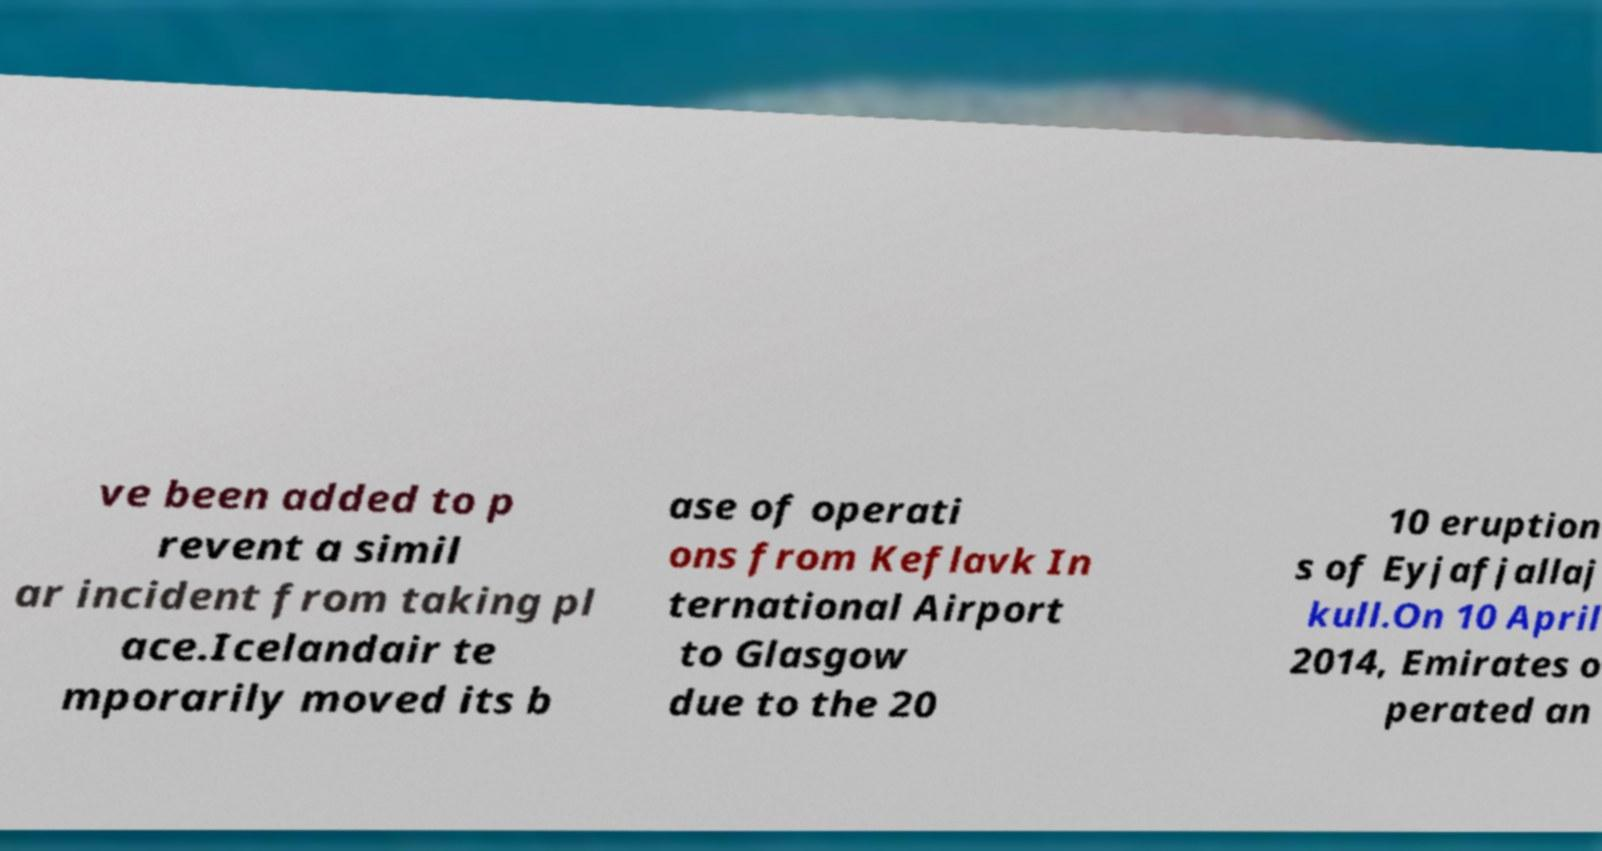Could you assist in decoding the text presented in this image and type it out clearly? ve been added to p revent a simil ar incident from taking pl ace.Icelandair te mporarily moved its b ase of operati ons from Keflavk In ternational Airport to Glasgow due to the 20 10 eruption s of Eyjafjallaj kull.On 10 April 2014, Emirates o perated an 